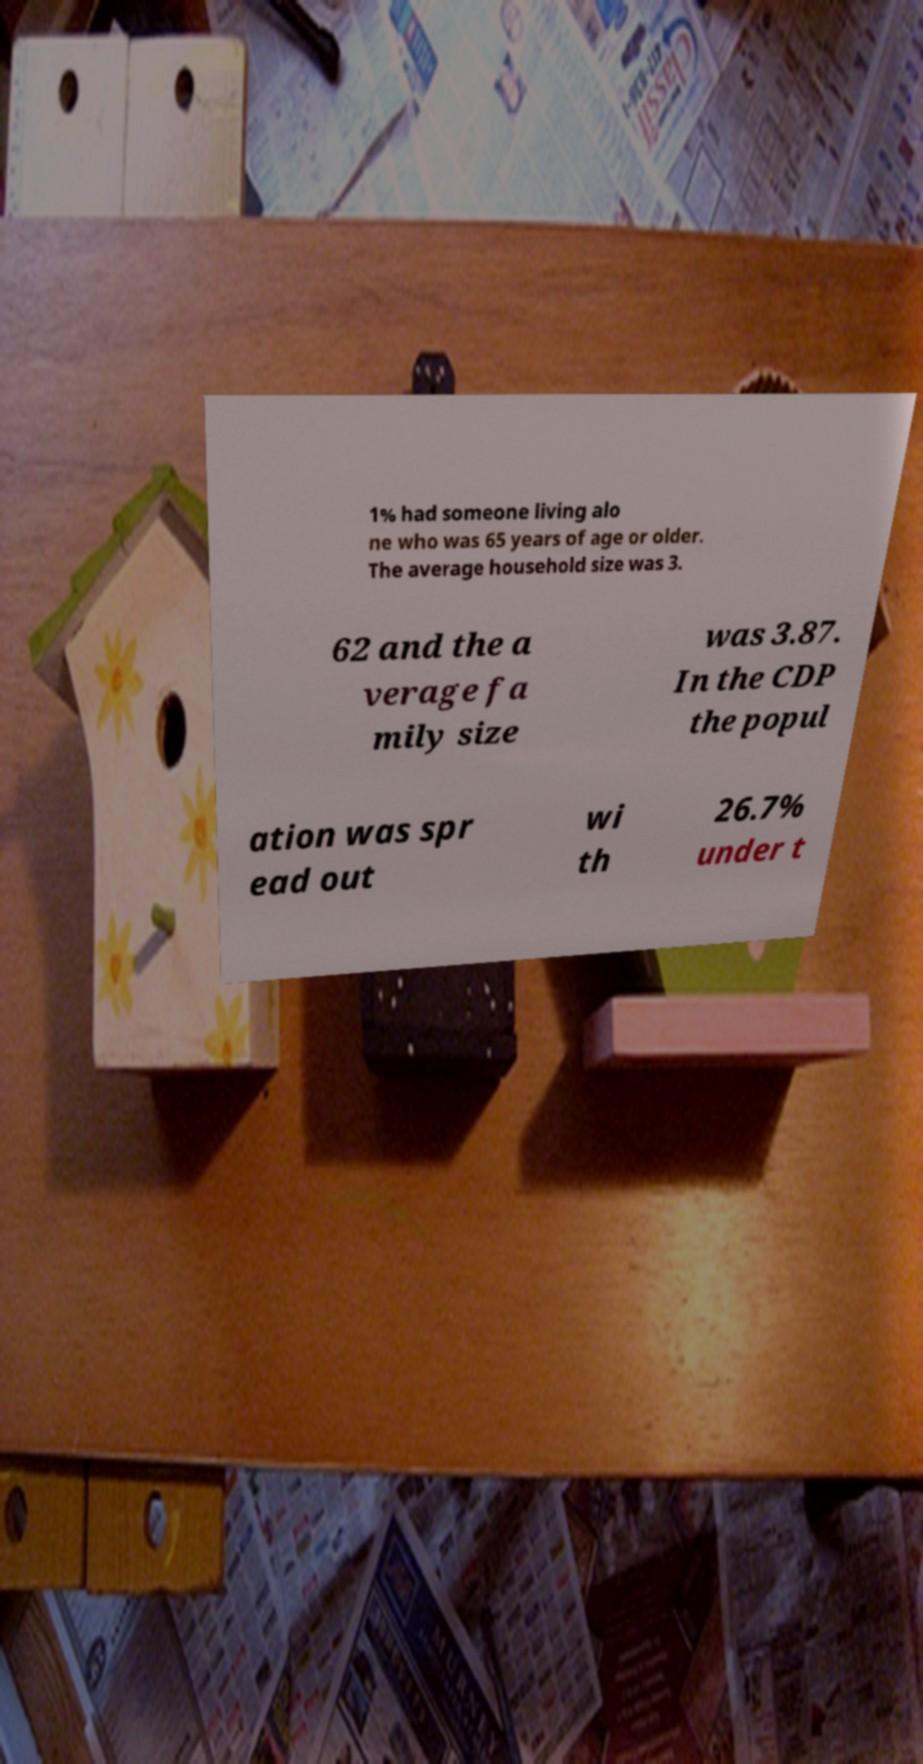For documentation purposes, I need the text within this image transcribed. Could you provide that? 1% had someone living alo ne who was 65 years of age or older. The average household size was 3. 62 and the a verage fa mily size was 3.87. In the CDP the popul ation was spr ead out wi th 26.7% under t 